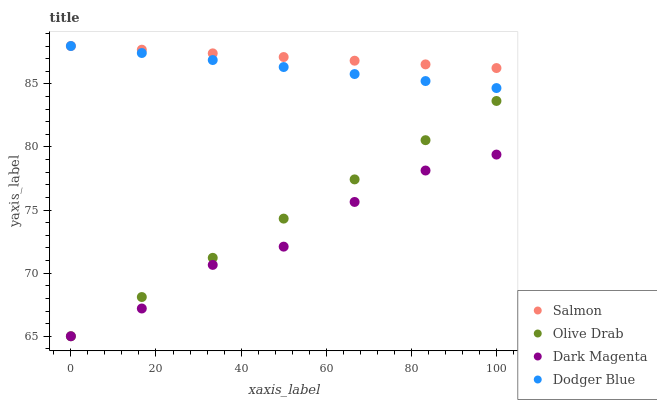Does Dark Magenta have the minimum area under the curve?
Answer yes or no. Yes. Does Salmon have the maximum area under the curve?
Answer yes or no. Yes. Does Salmon have the minimum area under the curve?
Answer yes or no. No. Does Dark Magenta have the maximum area under the curve?
Answer yes or no. No. Is Dodger Blue the smoothest?
Answer yes or no. Yes. Is Dark Magenta the roughest?
Answer yes or no. Yes. Is Salmon the smoothest?
Answer yes or no. No. Is Salmon the roughest?
Answer yes or no. No. Does Dark Magenta have the lowest value?
Answer yes or no. Yes. Does Salmon have the lowest value?
Answer yes or no. No. Does Salmon have the highest value?
Answer yes or no. Yes. Does Dark Magenta have the highest value?
Answer yes or no. No. Is Dark Magenta less than Dodger Blue?
Answer yes or no. Yes. Is Dodger Blue greater than Dark Magenta?
Answer yes or no. Yes. Does Dark Magenta intersect Olive Drab?
Answer yes or no. Yes. Is Dark Magenta less than Olive Drab?
Answer yes or no. No. Is Dark Magenta greater than Olive Drab?
Answer yes or no. No. Does Dark Magenta intersect Dodger Blue?
Answer yes or no. No. 